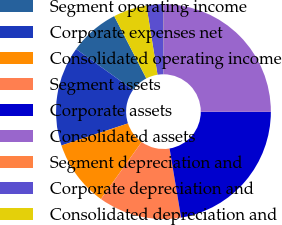Convert chart. <chart><loc_0><loc_0><loc_500><loc_500><pie_chart><fcel>Segment operating income<fcel>Corporate expenses net<fcel>Consolidated operating income<fcel>Segment assets<fcel>Corporate assets<fcel>Consolidated assets<fcel>Segment depreciation and<fcel>Corporate depreciation and<fcel>Consolidated depreciation and<nl><fcel>7.53%<fcel>15.0%<fcel>10.02%<fcel>12.51%<fcel>22.34%<fcel>24.95%<fcel>0.07%<fcel>2.55%<fcel>5.04%<nl></chart> 